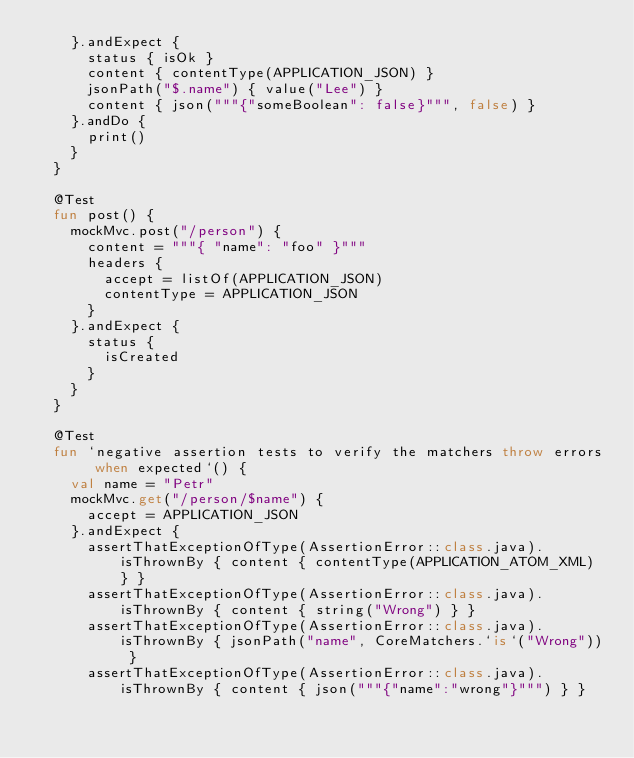Convert code to text. <code><loc_0><loc_0><loc_500><loc_500><_Kotlin_>		}.andExpect {
			status { isOk }
			content { contentType(APPLICATION_JSON) }
			jsonPath("$.name") { value("Lee") }
			content { json("""{"someBoolean": false}""", false) }
		}.andDo {
			print()
		}
	}

	@Test
	fun post() {
		mockMvc.post("/person") {
			content = """{ "name": "foo" }"""
			headers {
				accept = listOf(APPLICATION_JSON)
				contentType = APPLICATION_JSON
			}
		}.andExpect {
			status {
				isCreated
			}
		}
	}

	@Test
	fun `negative assertion tests to verify the matchers throw errors when expected`() {
		val name = "Petr"
		mockMvc.get("/person/$name") {
			accept = APPLICATION_JSON
		}.andExpect {
			assertThatExceptionOfType(AssertionError::class.java).isThrownBy { content { contentType(APPLICATION_ATOM_XML) } }
			assertThatExceptionOfType(AssertionError::class.java).isThrownBy { content { string("Wrong") } }
			assertThatExceptionOfType(AssertionError::class.java).isThrownBy { jsonPath("name", CoreMatchers.`is`("Wrong")) }
			assertThatExceptionOfType(AssertionError::class.java).isThrownBy { content { json("""{"name":"wrong"}""") } }</code> 